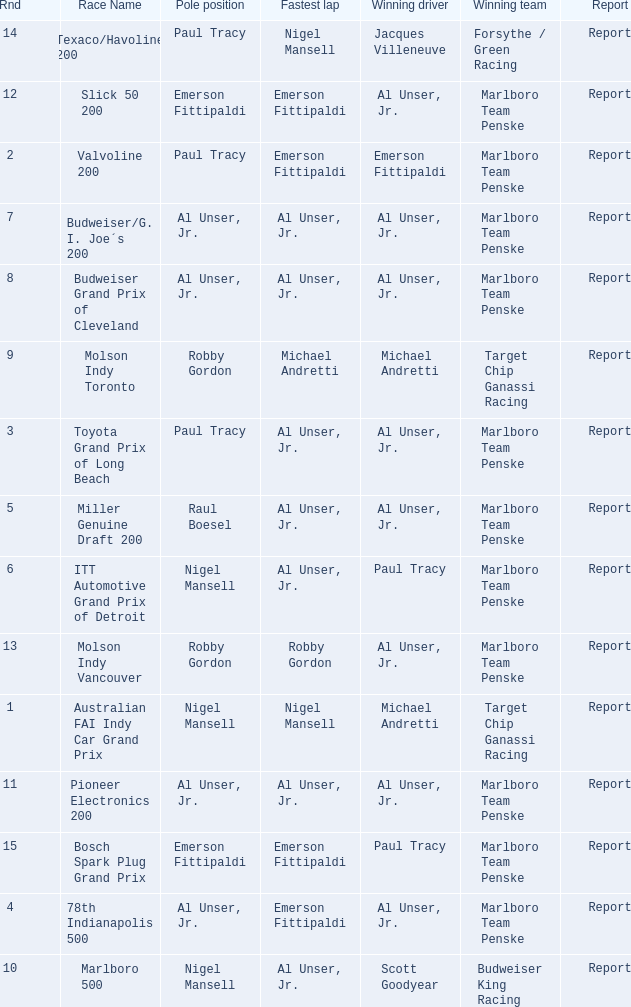Who was at the pole position in the ITT Automotive Grand Prix of Detroit, won by Paul Tracy? Nigel Mansell. 